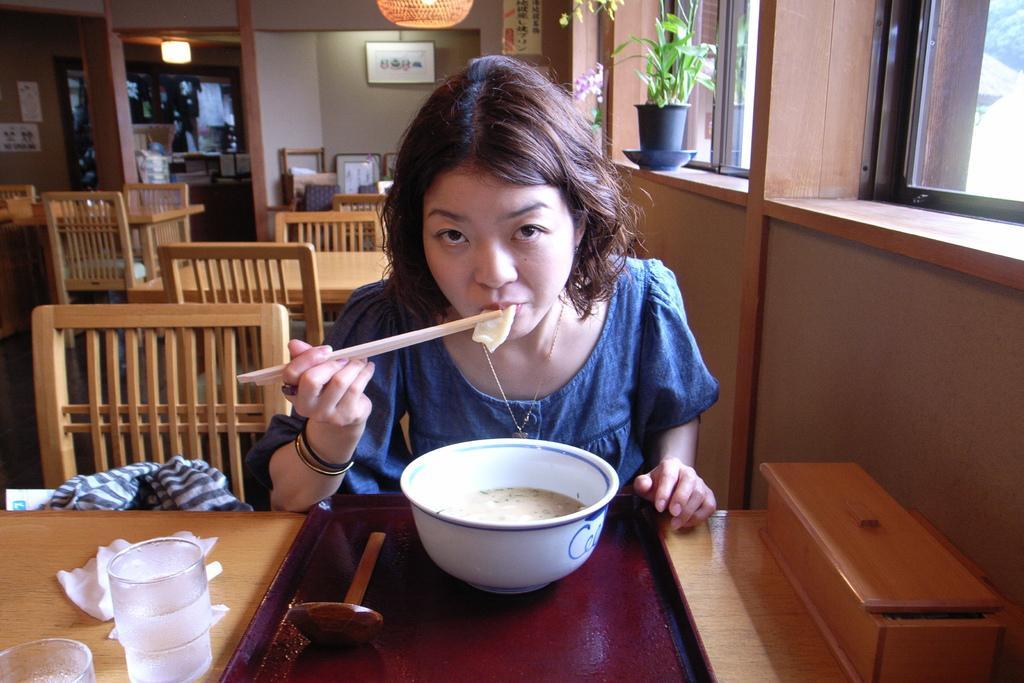Can you describe this image briefly? In the image there there is a woman who is sitting on chair holding chopsticks and eating something behind the table. On table we can see a bowl filled with some food,tray,glass,tissues in background we can see pillar,frames,wall which is in white color. On right side there is a plant with flower pot,windows. 